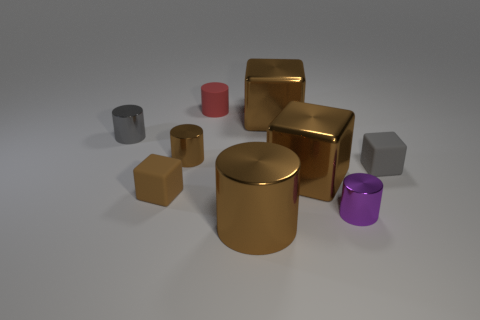How many objects in total are present in the image? There are ten objects in the image, including cylinders and cubes of varying colors and sizes. Are there more cubes than cylinders? Yes, there are more cubes than cylinders. The image contains seven cubes and three cylinders. 